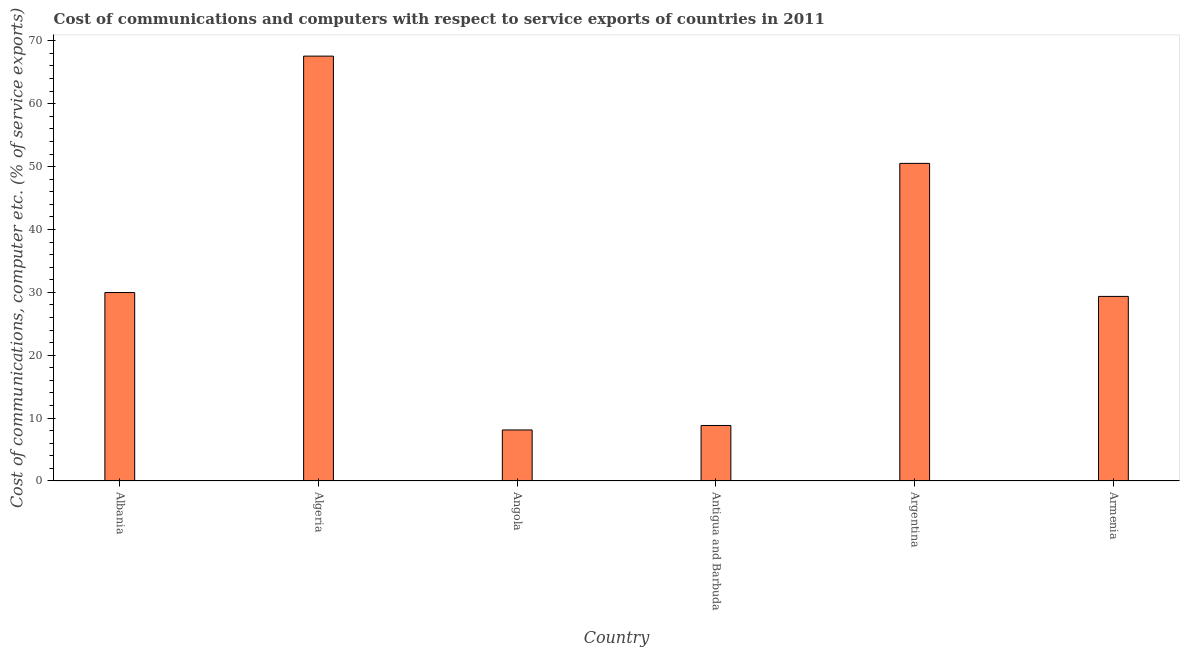What is the title of the graph?
Make the answer very short. Cost of communications and computers with respect to service exports of countries in 2011. What is the label or title of the X-axis?
Offer a very short reply. Country. What is the label or title of the Y-axis?
Ensure brevity in your answer.  Cost of communications, computer etc. (% of service exports). What is the cost of communications and computer in Antigua and Barbuda?
Your answer should be very brief. 8.83. Across all countries, what is the maximum cost of communications and computer?
Provide a succinct answer. 67.57. Across all countries, what is the minimum cost of communications and computer?
Provide a succinct answer. 8.11. In which country was the cost of communications and computer maximum?
Offer a very short reply. Algeria. In which country was the cost of communications and computer minimum?
Provide a succinct answer. Angola. What is the sum of the cost of communications and computer?
Your response must be concise. 194.35. What is the difference between the cost of communications and computer in Albania and Antigua and Barbuda?
Offer a very short reply. 21.14. What is the average cost of communications and computer per country?
Offer a very short reply. 32.39. What is the median cost of communications and computer?
Your response must be concise. 29.66. What is the ratio of the cost of communications and computer in Albania to that in Armenia?
Offer a terse response. 1.02. Is the cost of communications and computer in Antigua and Barbuda less than that in Argentina?
Make the answer very short. Yes. What is the difference between the highest and the second highest cost of communications and computer?
Your answer should be very brief. 17.06. Is the sum of the cost of communications and computer in Algeria and Argentina greater than the maximum cost of communications and computer across all countries?
Keep it short and to the point. Yes. What is the difference between the highest and the lowest cost of communications and computer?
Give a very brief answer. 59.45. In how many countries, is the cost of communications and computer greater than the average cost of communications and computer taken over all countries?
Your response must be concise. 2. How many bars are there?
Make the answer very short. 6. Are all the bars in the graph horizontal?
Provide a succinct answer. No. How many countries are there in the graph?
Provide a short and direct response. 6. What is the Cost of communications, computer etc. (% of service exports) of Albania?
Ensure brevity in your answer.  29.97. What is the Cost of communications, computer etc. (% of service exports) in Algeria?
Keep it short and to the point. 67.57. What is the Cost of communications, computer etc. (% of service exports) in Angola?
Make the answer very short. 8.11. What is the Cost of communications, computer etc. (% of service exports) in Antigua and Barbuda?
Your response must be concise. 8.83. What is the Cost of communications, computer etc. (% of service exports) of Argentina?
Your response must be concise. 50.51. What is the Cost of communications, computer etc. (% of service exports) in Armenia?
Make the answer very short. 29.35. What is the difference between the Cost of communications, computer etc. (% of service exports) in Albania and Algeria?
Your answer should be very brief. -37.6. What is the difference between the Cost of communications, computer etc. (% of service exports) in Albania and Angola?
Keep it short and to the point. 21.86. What is the difference between the Cost of communications, computer etc. (% of service exports) in Albania and Antigua and Barbuda?
Your answer should be compact. 21.14. What is the difference between the Cost of communications, computer etc. (% of service exports) in Albania and Argentina?
Ensure brevity in your answer.  -20.54. What is the difference between the Cost of communications, computer etc. (% of service exports) in Albania and Armenia?
Provide a short and direct response. 0.62. What is the difference between the Cost of communications, computer etc. (% of service exports) in Algeria and Angola?
Your response must be concise. 59.45. What is the difference between the Cost of communications, computer etc. (% of service exports) in Algeria and Antigua and Barbuda?
Provide a succinct answer. 58.74. What is the difference between the Cost of communications, computer etc. (% of service exports) in Algeria and Argentina?
Your answer should be very brief. 17.06. What is the difference between the Cost of communications, computer etc. (% of service exports) in Algeria and Armenia?
Provide a short and direct response. 38.22. What is the difference between the Cost of communications, computer etc. (% of service exports) in Angola and Antigua and Barbuda?
Ensure brevity in your answer.  -0.72. What is the difference between the Cost of communications, computer etc. (% of service exports) in Angola and Argentina?
Keep it short and to the point. -42.4. What is the difference between the Cost of communications, computer etc. (% of service exports) in Angola and Armenia?
Your answer should be compact. -21.24. What is the difference between the Cost of communications, computer etc. (% of service exports) in Antigua and Barbuda and Argentina?
Ensure brevity in your answer.  -41.68. What is the difference between the Cost of communications, computer etc. (% of service exports) in Antigua and Barbuda and Armenia?
Ensure brevity in your answer.  -20.52. What is the difference between the Cost of communications, computer etc. (% of service exports) in Argentina and Armenia?
Your response must be concise. 21.16. What is the ratio of the Cost of communications, computer etc. (% of service exports) in Albania to that in Algeria?
Ensure brevity in your answer.  0.44. What is the ratio of the Cost of communications, computer etc. (% of service exports) in Albania to that in Angola?
Ensure brevity in your answer.  3.69. What is the ratio of the Cost of communications, computer etc. (% of service exports) in Albania to that in Antigua and Barbuda?
Your response must be concise. 3.39. What is the ratio of the Cost of communications, computer etc. (% of service exports) in Albania to that in Argentina?
Offer a terse response. 0.59. What is the ratio of the Cost of communications, computer etc. (% of service exports) in Algeria to that in Angola?
Your answer should be very brief. 8.33. What is the ratio of the Cost of communications, computer etc. (% of service exports) in Algeria to that in Antigua and Barbuda?
Provide a short and direct response. 7.65. What is the ratio of the Cost of communications, computer etc. (% of service exports) in Algeria to that in Argentina?
Give a very brief answer. 1.34. What is the ratio of the Cost of communications, computer etc. (% of service exports) in Algeria to that in Armenia?
Your answer should be very brief. 2.3. What is the ratio of the Cost of communications, computer etc. (% of service exports) in Angola to that in Antigua and Barbuda?
Make the answer very short. 0.92. What is the ratio of the Cost of communications, computer etc. (% of service exports) in Angola to that in Argentina?
Your answer should be compact. 0.16. What is the ratio of the Cost of communications, computer etc. (% of service exports) in Angola to that in Armenia?
Provide a short and direct response. 0.28. What is the ratio of the Cost of communications, computer etc. (% of service exports) in Antigua and Barbuda to that in Argentina?
Give a very brief answer. 0.17. What is the ratio of the Cost of communications, computer etc. (% of service exports) in Antigua and Barbuda to that in Armenia?
Your answer should be compact. 0.3. What is the ratio of the Cost of communications, computer etc. (% of service exports) in Argentina to that in Armenia?
Provide a succinct answer. 1.72. 